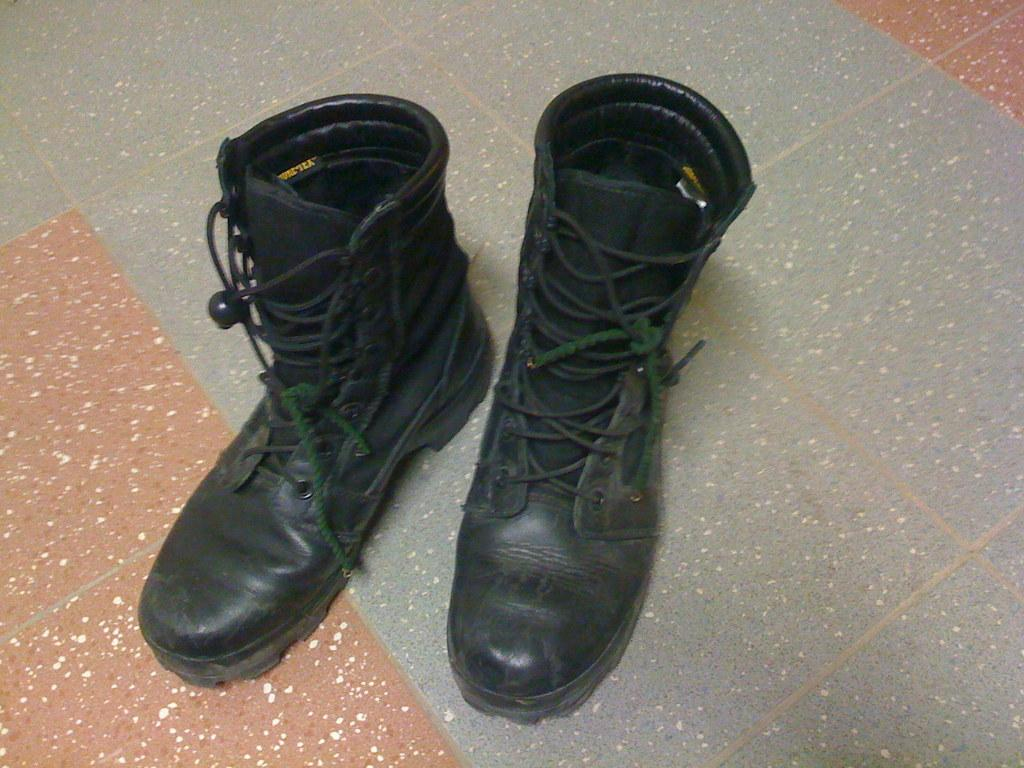What type of footwear is present in the image? There is a pair of boots in the image. Where are the boots located in the image? The boots are on the floor. What color is the balloon tied to the boots in the image? There is no balloon present in the image; it only features a pair of boots on the floor. 